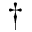Convert formula to latex. <formula><loc_0><loc_0><loc_500><loc_500>^ { \dagger }</formula> 